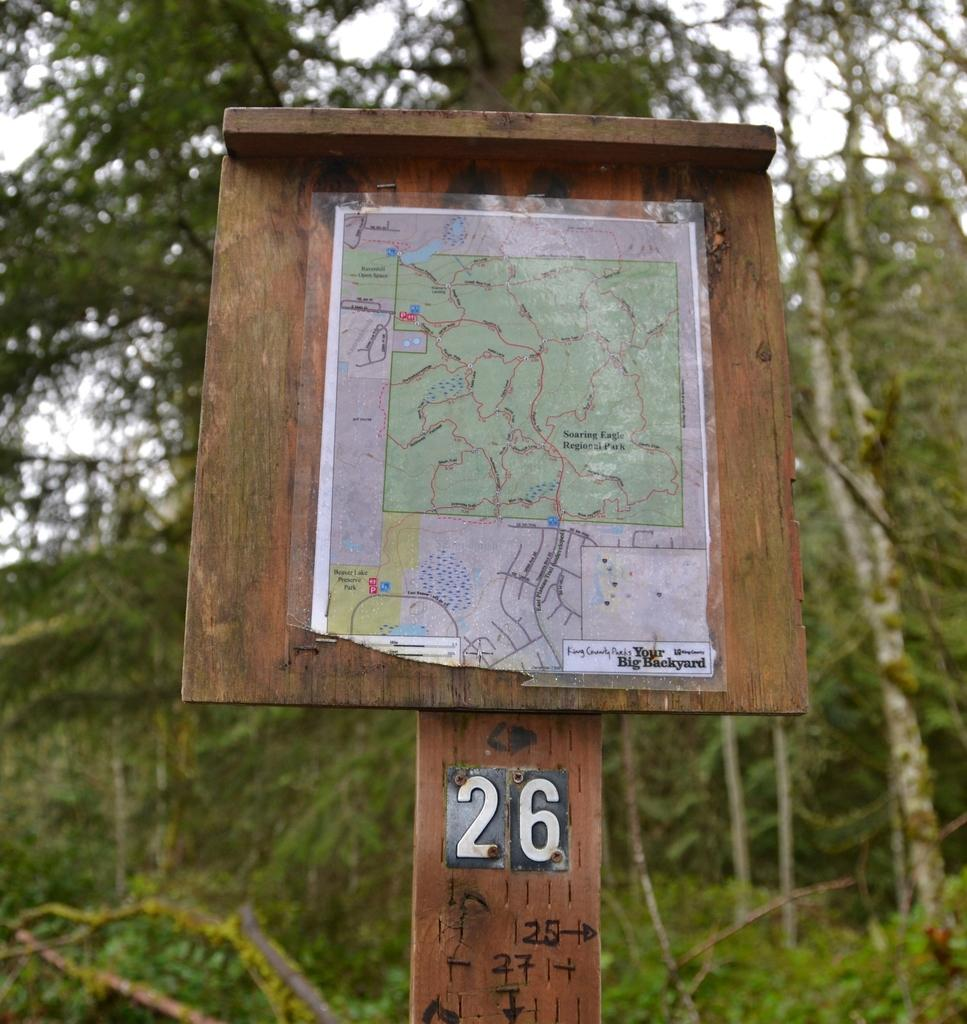What is the main object on the wooden board in the image? There is a map on a wooden board in the image. What can be seen in the background of the image? There are trees in the background of the image. What color is the leg of the person standing next to the wooden board in the image? There is no person standing next to the wooden board in the image, so it is not possible to determine the color of their leg. 